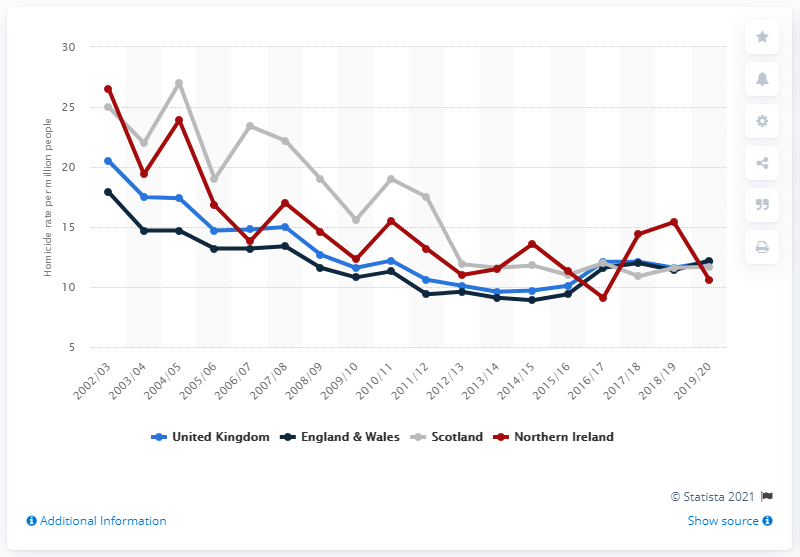Draw attention to some important aspects in this diagram. In the UK in 2019/20, the homicide rate was 12.1 per million people. The UK's homicide rate in the previous year was 11.6. 